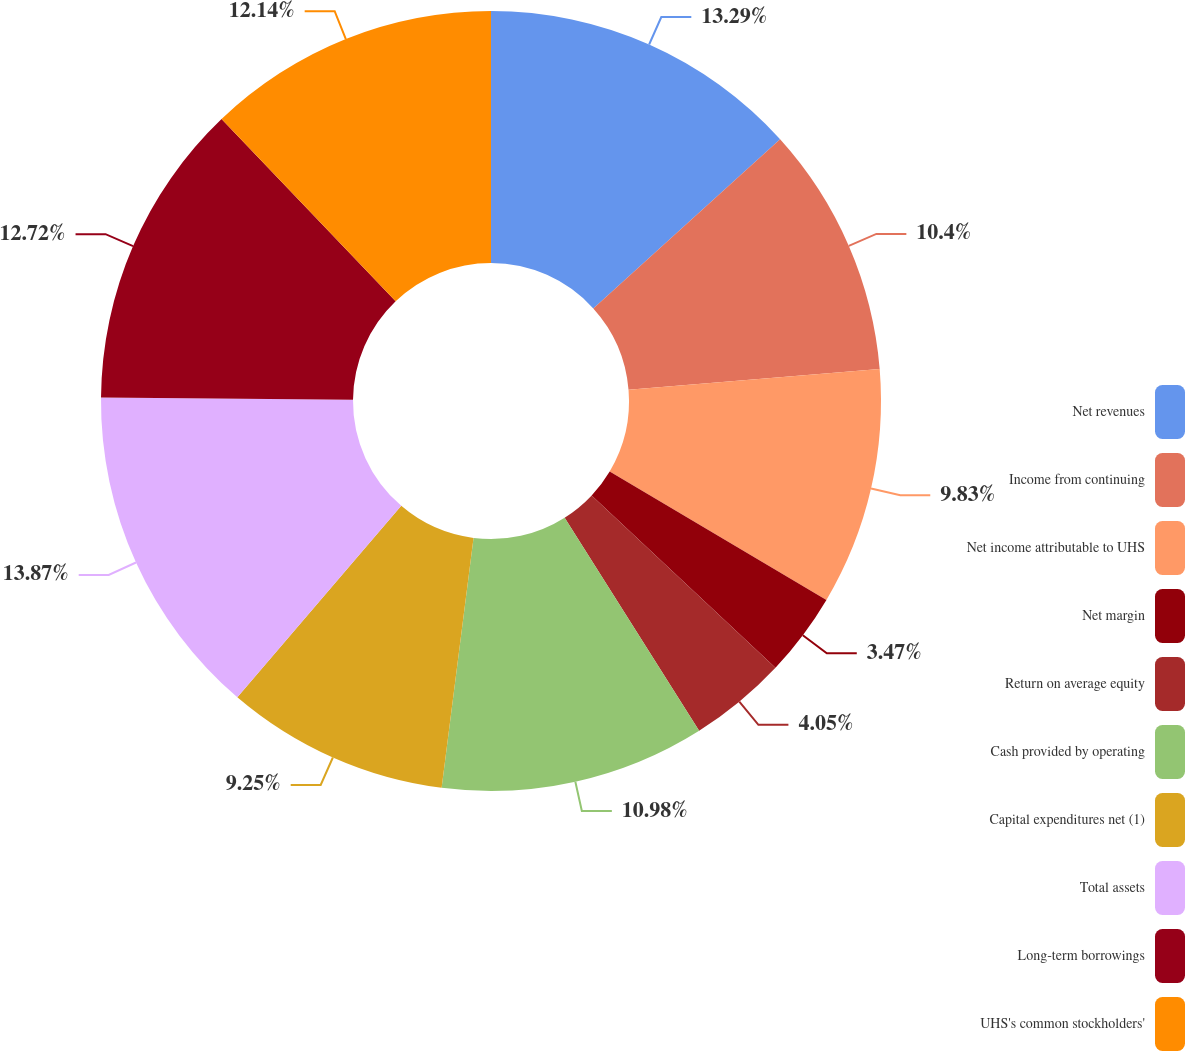<chart> <loc_0><loc_0><loc_500><loc_500><pie_chart><fcel>Net revenues<fcel>Income from continuing<fcel>Net income attributable to UHS<fcel>Net margin<fcel>Return on average equity<fcel>Cash provided by operating<fcel>Capital expenditures net (1)<fcel>Total assets<fcel>Long-term borrowings<fcel>UHS's common stockholders'<nl><fcel>13.29%<fcel>10.4%<fcel>9.83%<fcel>3.47%<fcel>4.05%<fcel>10.98%<fcel>9.25%<fcel>13.87%<fcel>12.72%<fcel>12.14%<nl></chart> 